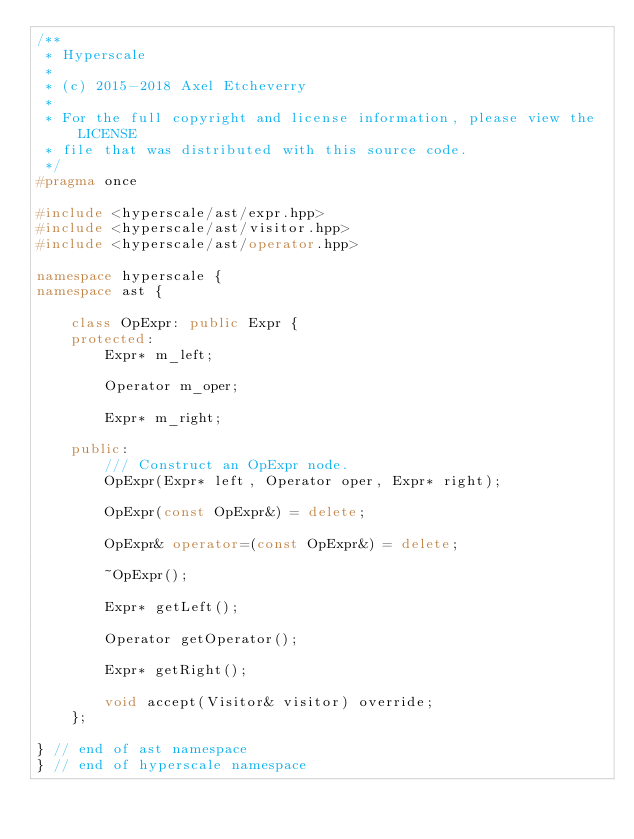Convert code to text. <code><loc_0><loc_0><loc_500><loc_500><_C++_>/**
 * Hyperscale
 *
 * (c) 2015-2018 Axel Etcheverry
 *
 * For the full copyright and license information, please view the LICENSE
 * file that was distributed with this source code.
 */
#pragma once

#include <hyperscale/ast/expr.hpp>
#include <hyperscale/ast/visitor.hpp>
#include <hyperscale/ast/operator.hpp>

namespace hyperscale {
namespace ast {

    class OpExpr: public Expr {
    protected:
        Expr* m_left;

        Operator m_oper;

        Expr* m_right;

    public:
        /// Construct an OpExpr node.
        OpExpr(Expr* left, Operator oper, Expr* right);

        OpExpr(const OpExpr&) = delete;

        OpExpr& operator=(const OpExpr&) = delete;

        ~OpExpr();

        Expr* getLeft();

        Operator getOperator();

        Expr* getRight();

        void accept(Visitor& visitor) override;
    };

} // end of ast namespace
} // end of hyperscale namespace

</code> 